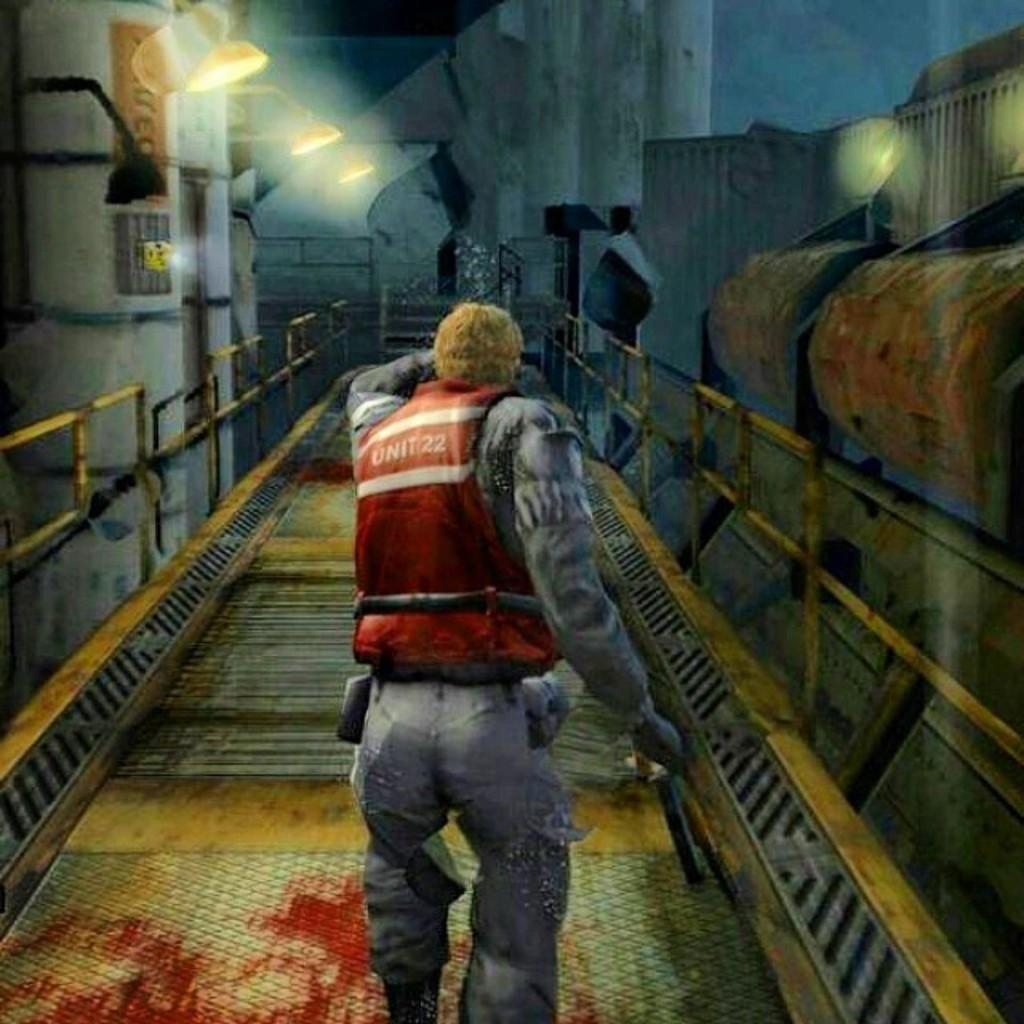Please provide a concise description of this image. This is an animated image. A person is walking. There are lights and pillars. 